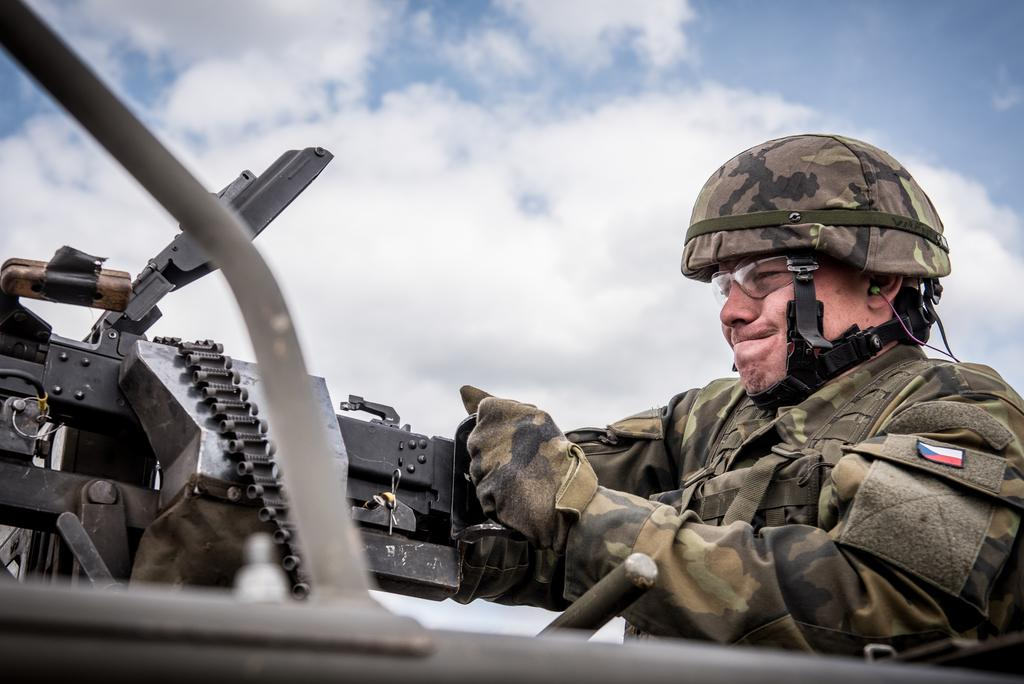What is the main subject of the image? There is a person in the image. What is the person doing in the image? The person is operating a machine gun. What can be seen in the background of the image? The sky is visible in the image. How would you describe the weather based on the sky in the image? The sky appears to be cloudy. How many volleyballs are being used by the person in the image? There are no volleyballs present in the image. What level of expertise does the person in the image have with machine guns? The image does not provide information about the person's level of expertise with machine guns. 